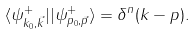<formula> <loc_0><loc_0><loc_500><loc_500>\langle \psi _ { k _ { 0 } , \vec { k } } ^ { + } | | \psi _ { p _ { 0 } , \vec { p } } ^ { + } \rangle = \delta ^ { n } ( k - p ) .</formula> 